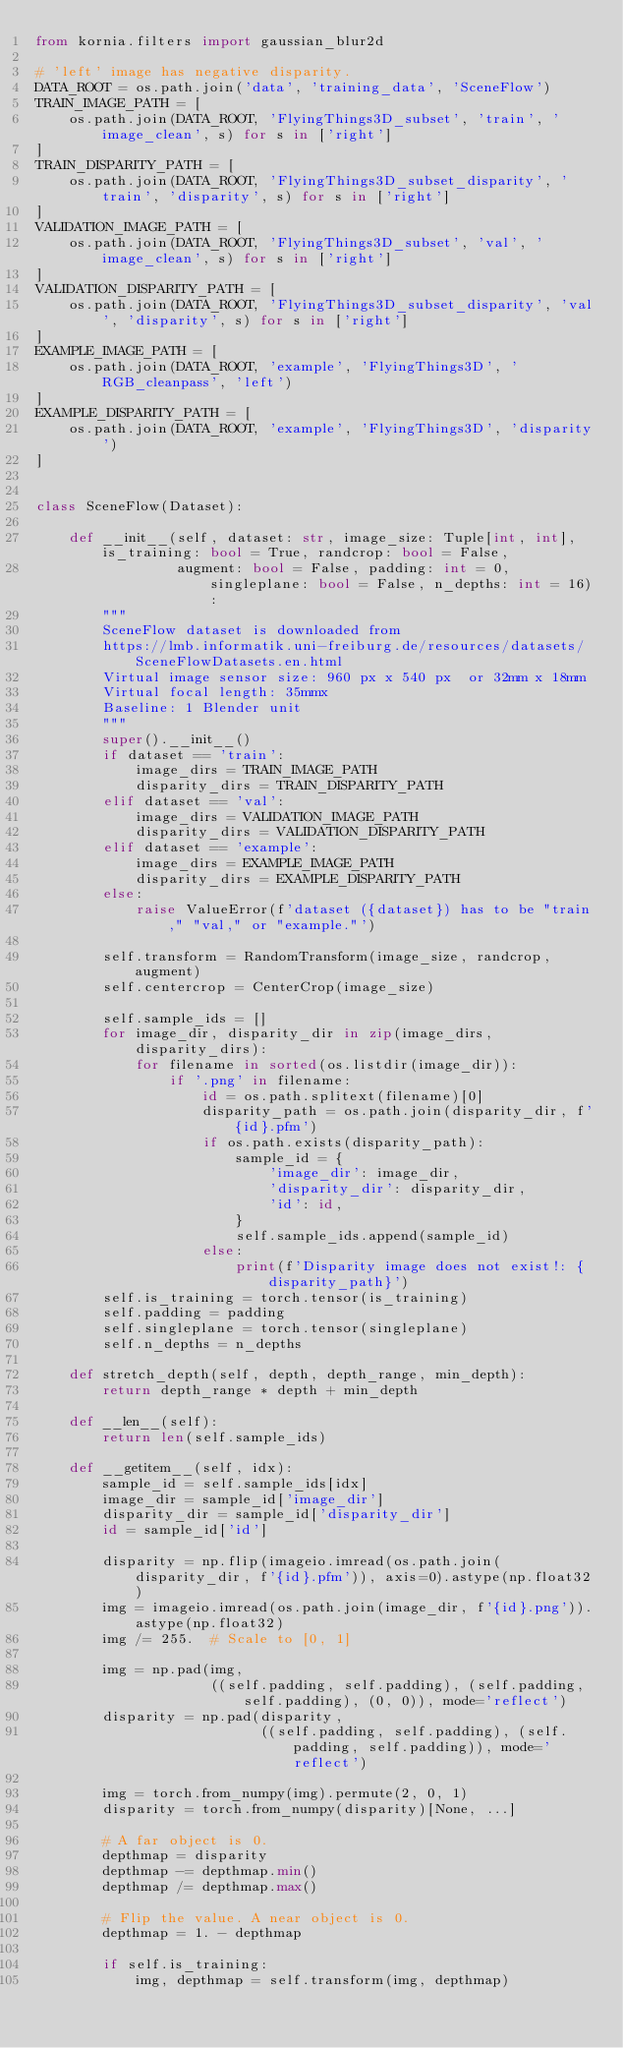Convert code to text. <code><loc_0><loc_0><loc_500><loc_500><_Python_>from kornia.filters import gaussian_blur2d

# 'left' image has negative disparity.
DATA_ROOT = os.path.join('data', 'training_data', 'SceneFlow')
TRAIN_IMAGE_PATH = [
    os.path.join(DATA_ROOT, 'FlyingThings3D_subset', 'train', 'image_clean', s) for s in ['right']
]
TRAIN_DISPARITY_PATH = [
    os.path.join(DATA_ROOT, 'FlyingThings3D_subset_disparity', 'train', 'disparity', s) for s in ['right']
]
VALIDATION_IMAGE_PATH = [
    os.path.join(DATA_ROOT, 'FlyingThings3D_subset', 'val', 'image_clean', s) for s in ['right']
]
VALIDATION_DISPARITY_PATH = [
    os.path.join(DATA_ROOT, 'FlyingThings3D_subset_disparity', 'val', 'disparity', s) for s in ['right']
]
EXAMPLE_IMAGE_PATH = [
    os.path.join(DATA_ROOT, 'example', 'FlyingThings3D', 'RGB_cleanpass', 'left')
]
EXAMPLE_DISPARITY_PATH = [
    os.path.join(DATA_ROOT, 'example', 'FlyingThings3D', 'disparity')
]


class SceneFlow(Dataset):

    def __init__(self, dataset: str, image_size: Tuple[int, int], is_training: bool = True, randcrop: bool = False,
                 augment: bool = False, padding: int = 0, singleplane: bool = False, n_depths: int = 16):
        """
        SceneFlow dataset is downloaded from
        https://lmb.informatik.uni-freiburg.de/resources/datasets/SceneFlowDatasets.en.html
        Virtual image sensor size: 960 px x 540 px  or 32mm x 18mm
        Virtual focal length: 35mmx
        Baseline: 1 Blender unit
        """
        super().__init__()
        if dataset == 'train':
            image_dirs = TRAIN_IMAGE_PATH
            disparity_dirs = TRAIN_DISPARITY_PATH
        elif dataset == 'val':
            image_dirs = VALIDATION_IMAGE_PATH
            disparity_dirs = VALIDATION_DISPARITY_PATH
        elif dataset == 'example':
            image_dirs = EXAMPLE_IMAGE_PATH
            disparity_dirs = EXAMPLE_DISPARITY_PATH
        else:
            raise ValueError(f'dataset ({dataset}) has to be "train," "val," or "example."')

        self.transform = RandomTransform(image_size, randcrop, augment)
        self.centercrop = CenterCrop(image_size)

        self.sample_ids = []
        for image_dir, disparity_dir in zip(image_dirs, disparity_dirs):
            for filename in sorted(os.listdir(image_dir)):
                if '.png' in filename:
                    id = os.path.splitext(filename)[0]
                    disparity_path = os.path.join(disparity_dir, f'{id}.pfm')
                    if os.path.exists(disparity_path):
                        sample_id = {
                            'image_dir': image_dir,
                            'disparity_dir': disparity_dir,
                            'id': id,
                        }
                        self.sample_ids.append(sample_id)
                    else:
                        print(f'Disparity image does not exist!: {disparity_path}')
        self.is_training = torch.tensor(is_training)
        self.padding = padding
        self.singleplane = torch.tensor(singleplane)
        self.n_depths = n_depths

    def stretch_depth(self, depth, depth_range, min_depth):
        return depth_range * depth + min_depth

    def __len__(self):
        return len(self.sample_ids)

    def __getitem__(self, idx):
        sample_id = self.sample_ids[idx]
        image_dir = sample_id['image_dir']
        disparity_dir = sample_id['disparity_dir']
        id = sample_id['id']

        disparity = np.flip(imageio.imread(os.path.join(disparity_dir, f'{id}.pfm')), axis=0).astype(np.float32)
        img = imageio.imread(os.path.join(image_dir, f'{id}.png')).astype(np.float32)
        img /= 255.  # Scale to [0, 1]

        img = np.pad(img,
                     ((self.padding, self.padding), (self.padding, self.padding), (0, 0)), mode='reflect')
        disparity = np.pad(disparity,
                           ((self.padding, self.padding), (self.padding, self.padding)), mode='reflect')

        img = torch.from_numpy(img).permute(2, 0, 1)
        disparity = torch.from_numpy(disparity)[None, ...]

        # A far object is 0.
        depthmap = disparity
        depthmap -= depthmap.min()
        depthmap /= depthmap.max()

        # Flip the value. A near object is 0.
        depthmap = 1. - depthmap

        if self.is_training:
            img, depthmap = self.transform(img, depthmap)</code> 